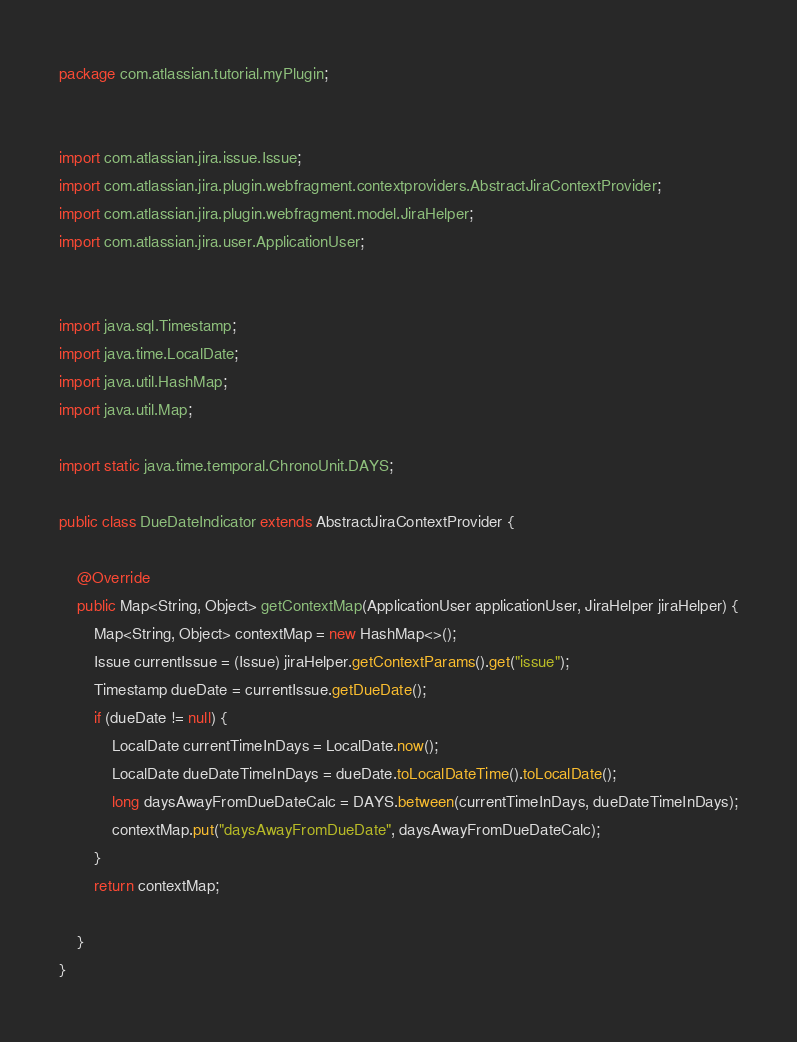<code> <loc_0><loc_0><loc_500><loc_500><_Java_>package com.atlassian.tutorial.myPlugin;


import com.atlassian.jira.issue.Issue;
import com.atlassian.jira.plugin.webfragment.contextproviders.AbstractJiraContextProvider;
import com.atlassian.jira.plugin.webfragment.model.JiraHelper;
import com.atlassian.jira.user.ApplicationUser;


import java.sql.Timestamp;
import java.time.LocalDate;
import java.util.HashMap;
import java.util.Map;

import static java.time.temporal.ChronoUnit.DAYS;

public class DueDateIndicator extends AbstractJiraContextProvider {

    @Override
    public Map<String, Object> getContextMap(ApplicationUser applicationUser, JiraHelper jiraHelper) {
        Map<String, Object> contextMap = new HashMap<>();
        Issue currentIssue = (Issue) jiraHelper.getContextParams().get("issue");
        Timestamp dueDate = currentIssue.getDueDate();
        if (dueDate != null) {
            LocalDate currentTimeInDays = LocalDate.now();
            LocalDate dueDateTimeInDays = dueDate.toLocalDateTime().toLocalDate();
            long daysAwayFromDueDateCalc = DAYS.between(currentTimeInDays, dueDateTimeInDays);
            contextMap.put("daysAwayFromDueDate", daysAwayFromDueDateCalc);
        }
        return contextMap;

    }
}
</code> 